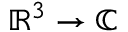<formula> <loc_0><loc_0><loc_500><loc_500>\mathbb { R } ^ { 3 } \to \mathbb { C }</formula> 